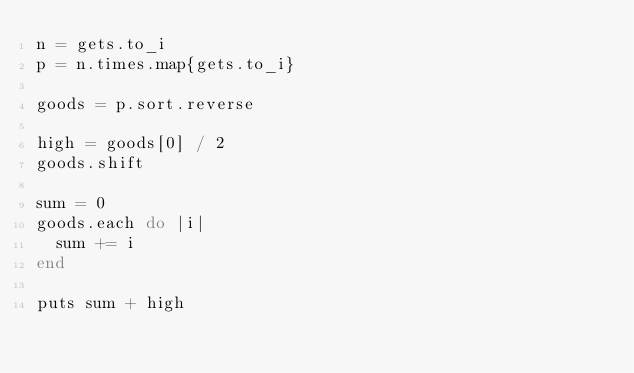<code> <loc_0><loc_0><loc_500><loc_500><_Ruby_>n = gets.to_i
p = n.times.map{gets.to_i}

goods = p.sort.reverse

high = goods[0] / 2
goods.shift

sum = 0
goods.each do |i|
  sum += i
end

puts sum + high</code> 